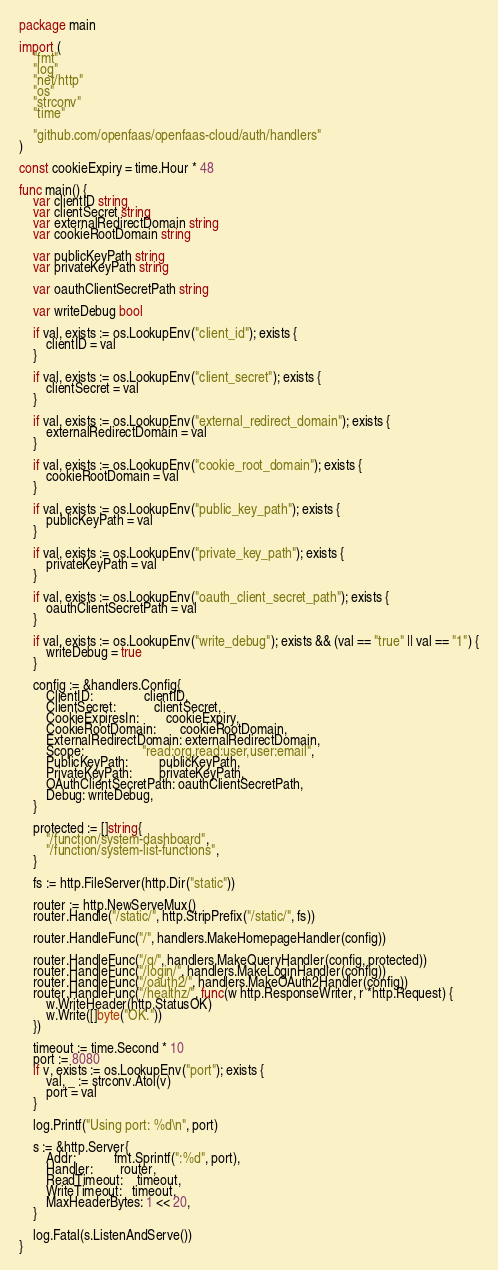<code> <loc_0><loc_0><loc_500><loc_500><_Go_>package main

import (
	"fmt"
	"log"
	"net/http"
	"os"
	"strconv"
	"time"

	"github.com/openfaas/openfaas-cloud/auth/handlers"
)

const cookieExpiry = time.Hour * 48

func main() {
	var clientID string
	var clientSecret string
	var externalRedirectDomain string
	var cookieRootDomain string

	var publicKeyPath string
	var privateKeyPath string

	var oauthClientSecretPath string

	var writeDebug bool

	if val, exists := os.LookupEnv("client_id"); exists {
		clientID = val
	}

	if val, exists := os.LookupEnv("client_secret"); exists {
		clientSecret = val
	}

	if val, exists := os.LookupEnv("external_redirect_domain"); exists {
		externalRedirectDomain = val
	}

	if val, exists := os.LookupEnv("cookie_root_domain"); exists {
		cookieRootDomain = val
	}

	if val, exists := os.LookupEnv("public_key_path"); exists {
		publicKeyPath = val
	}

	if val, exists := os.LookupEnv("private_key_path"); exists {
		privateKeyPath = val
	}

	if val, exists := os.LookupEnv("oauth_client_secret_path"); exists {
		oauthClientSecretPath = val
	}

	if val, exists := os.LookupEnv("write_debug"); exists && (val == "true" || val == "1") {
		writeDebug = true
	}

	config := &handlers.Config{
		ClientID:               clientID,
		ClientSecret:           clientSecret,
		CookieExpiresIn:        cookieExpiry,
		CookieRootDomain:       cookieRootDomain,
		ExternalRedirectDomain: externalRedirectDomain,
		Scope:                 "read:org,read:user,user:email",
		PublicKeyPath:         publicKeyPath,
		PrivateKeyPath:        privateKeyPath,
		OAuthClientSecretPath: oauthClientSecretPath,
		Debug: writeDebug,
	}

	protected := []string{
		"/function/system-dashboard",
		"/function/system-list-functions",
	}

	fs := http.FileServer(http.Dir("static"))

	router := http.NewServeMux()
	router.Handle("/static/", http.StripPrefix("/static/", fs))

	router.HandleFunc("/", handlers.MakeHomepageHandler(config))

	router.HandleFunc("/q/", handlers.MakeQueryHandler(config, protected))
	router.HandleFunc("/login/", handlers.MakeLoginHandler(config))
	router.HandleFunc("/oauth2/", handlers.MakeOAuth2Handler(config))
	router.HandleFunc("/healthz/", func(w http.ResponseWriter, r *http.Request) {
		w.WriteHeader(http.StatusOK)
		w.Write([]byte("OK."))
	})

	timeout := time.Second * 10
	port := 8080
	if v, exists := os.LookupEnv("port"); exists {
		val, _ := strconv.Atoi(v)
		port = val
	}

	log.Printf("Using port: %d\n", port)

	s := &http.Server{
		Addr:           fmt.Sprintf(":%d", port),
		Handler:        router,
		ReadTimeout:    timeout,
		WriteTimeout:   timeout,
		MaxHeaderBytes: 1 << 20,
	}

	log.Fatal(s.ListenAndServe())
}
</code> 